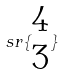Convert formula to latex. <formula><loc_0><loc_0><loc_500><loc_500>s r \{ \begin{matrix} 4 \\ 3 \end{matrix} \}</formula> 